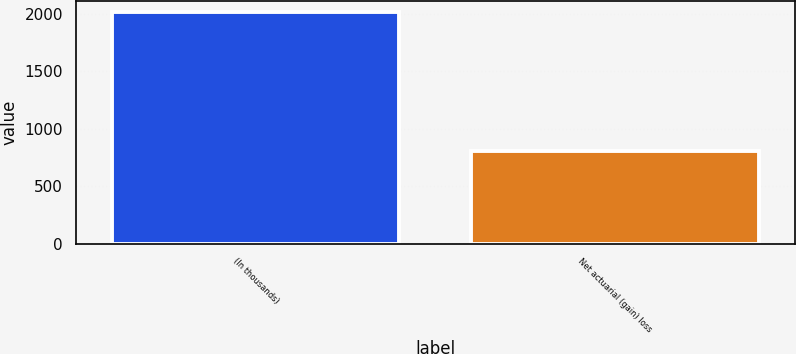Convert chart to OTSL. <chart><loc_0><loc_0><loc_500><loc_500><bar_chart><fcel>(In thousands)<fcel>Net actuarial (gain) loss<nl><fcel>2014<fcel>803<nl></chart> 